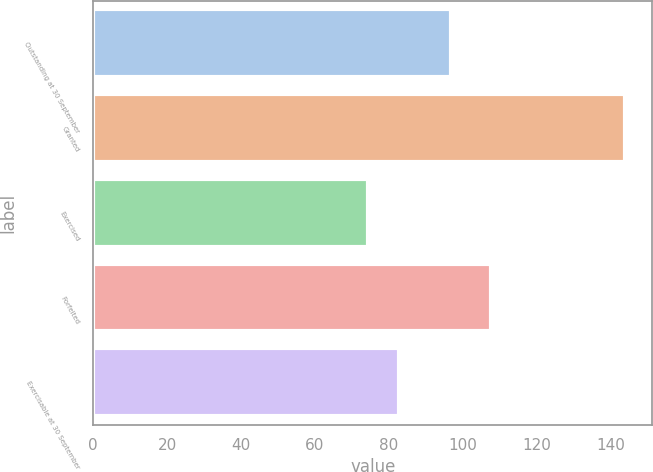<chart> <loc_0><loc_0><loc_500><loc_500><bar_chart><fcel>Outstanding at 30 September<fcel>Granted<fcel>Exercised<fcel>Forfeited<fcel>Exercisable at 30 September<nl><fcel>96.75<fcel>144.09<fcel>74.35<fcel>107.7<fcel>82.81<nl></chart> 